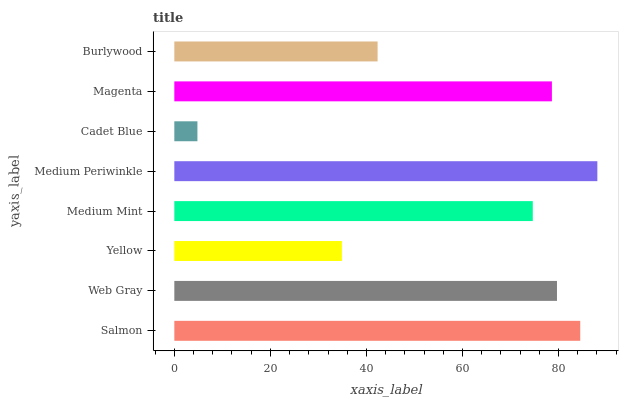Is Cadet Blue the minimum?
Answer yes or no. Yes. Is Medium Periwinkle the maximum?
Answer yes or no. Yes. Is Web Gray the minimum?
Answer yes or no. No. Is Web Gray the maximum?
Answer yes or no. No. Is Salmon greater than Web Gray?
Answer yes or no. Yes. Is Web Gray less than Salmon?
Answer yes or no. Yes. Is Web Gray greater than Salmon?
Answer yes or no. No. Is Salmon less than Web Gray?
Answer yes or no. No. Is Magenta the high median?
Answer yes or no. Yes. Is Medium Mint the low median?
Answer yes or no. Yes. Is Medium Periwinkle the high median?
Answer yes or no. No. Is Burlywood the low median?
Answer yes or no. No. 